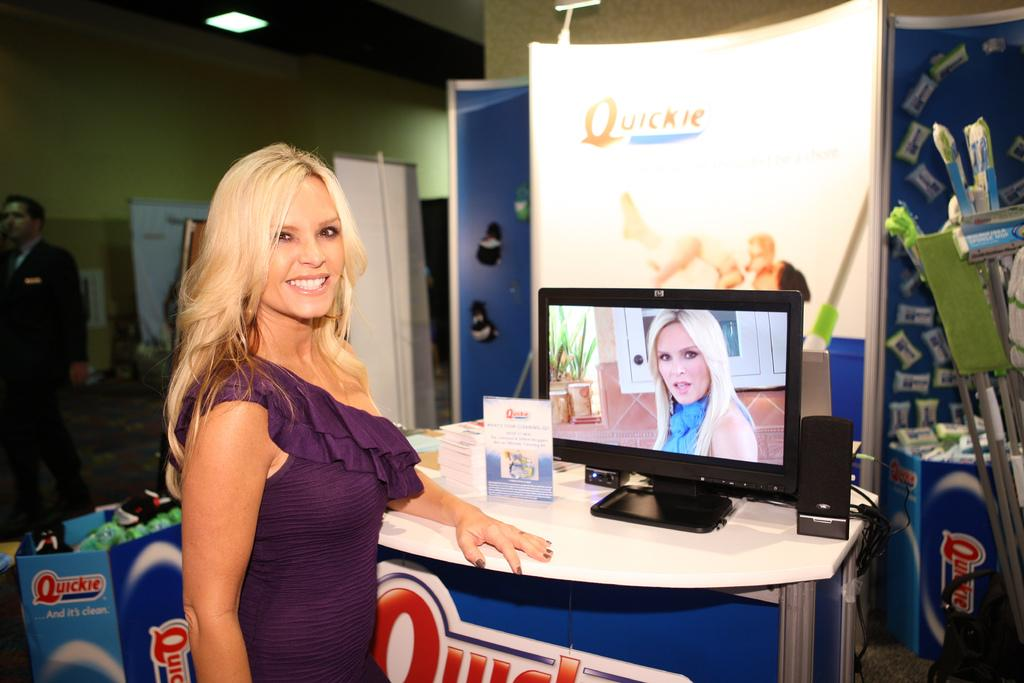<image>
Describe the image concisely. A woman stands in front of a HP Computer monitors at a Quickie display. 